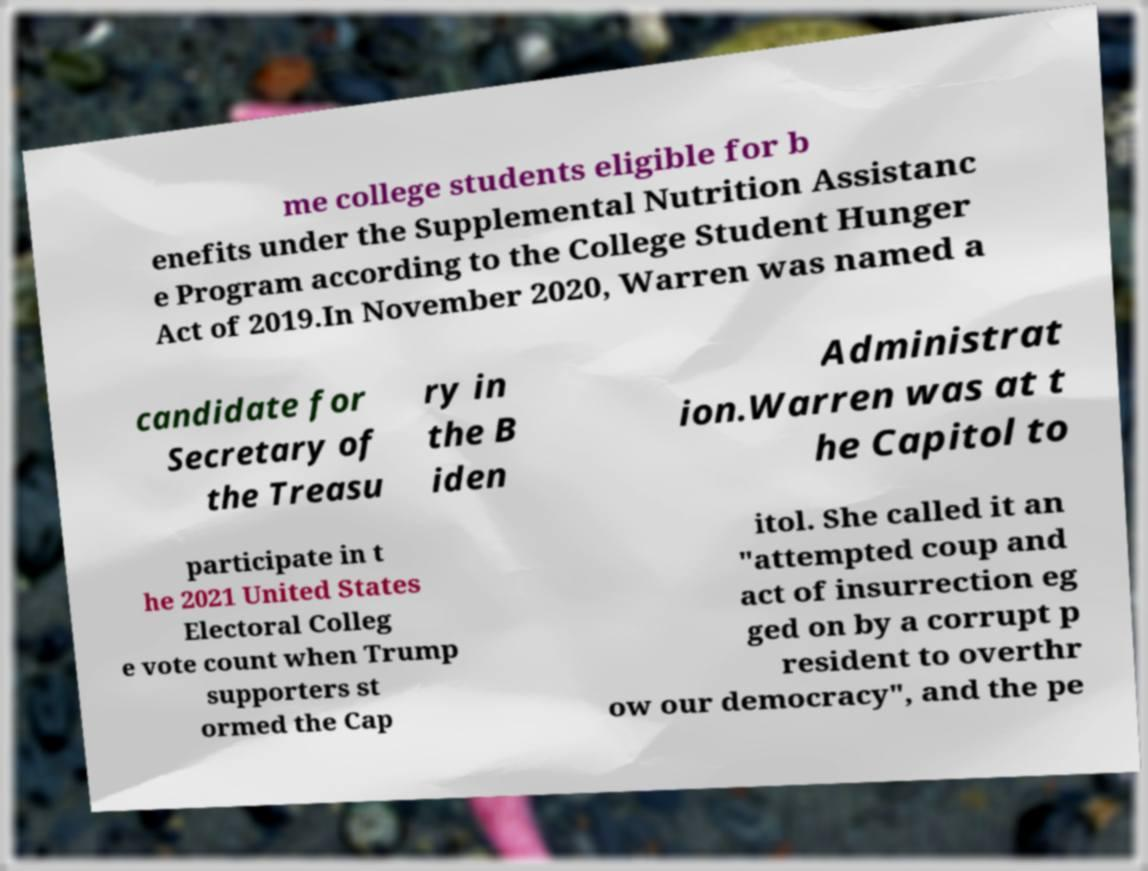I need the written content from this picture converted into text. Can you do that? me college students eligible for b enefits under the Supplemental Nutrition Assistanc e Program according to the College Student Hunger Act of 2019.In November 2020, Warren was named a candidate for Secretary of the Treasu ry in the B iden Administrat ion.Warren was at t he Capitol to participate in t he 2021 United States Electoral Colleg e vote count when Trump supporters st ormed the Cap itol. She called it an "attempted coup and act of insurrection eg ged on by a corrupt p resident to overthr ow our democracy", and the pe 